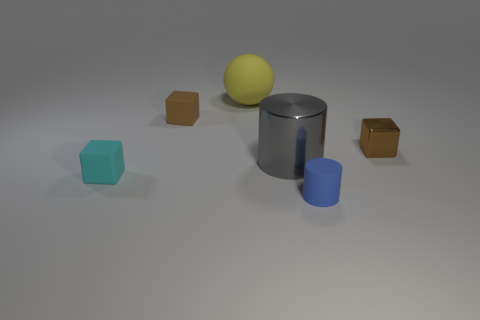Add 3 large yellow rubber objects. How many objects exist? 9 Subtract all balls. How many objects are left? 5 Add 1 small blue rubber cylinders. How many small blue rubber cylinders are left? 2 Add 6 large yellow things. How many large yellow things exist? 7 Subtract 0 brown spheres. How many objects are left? 6 Subtract all tiny objects. Subtract all blue rubber cylinders. How many objects are left? 1 